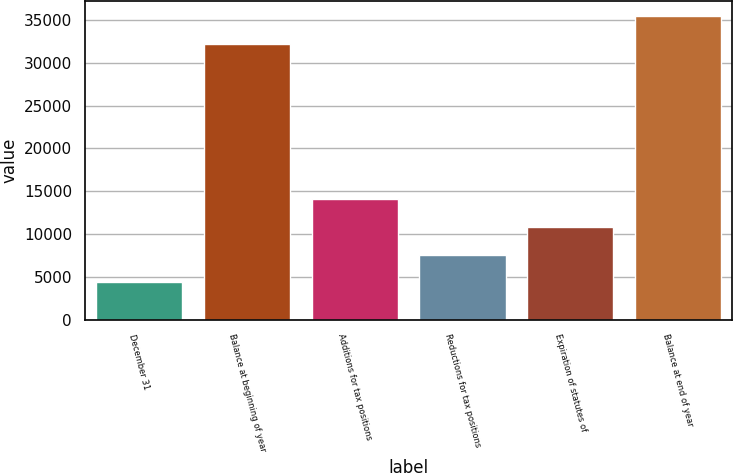Convert chart to OTSL. <chart><loc_0><loc_0><loc_500><loc_500><bar_chart><fcel>December 31<fcel>Balance at beginning of year<fcel>Additions for tax positions<fcel>Reductions for tax positions<fcel>Expiration of statutes of<fcel>Balance at end of year<nl><fcel>4350.9<fcel>32230<fcel>14037.6<fcel>7579.8<fcel>10808.7<fcel>35458.9<nl></chart> 